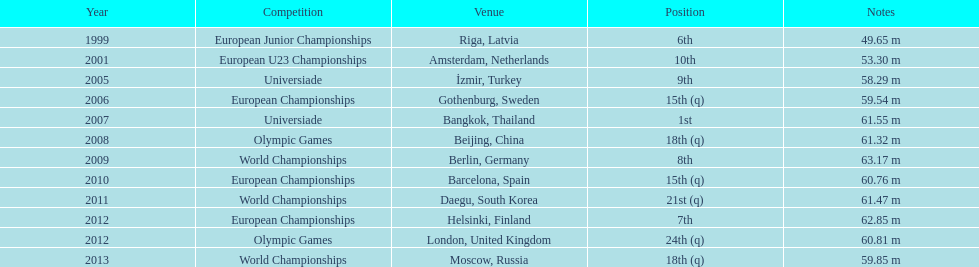Name two events in which mayer competed before he won the bangkok universiade. European Championships, Universiade. 